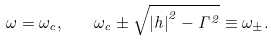Convert formula to latex. <formula><loc_0><loc_0><loc_500><loc_500>\omega = \omega _ { c } , \quad \omega _ { c } \pm \sqrt { { | h | } ^ { 2 } - \Gamma ^ { 2 } } \equiv \omega _ { \pm } .</formula> 